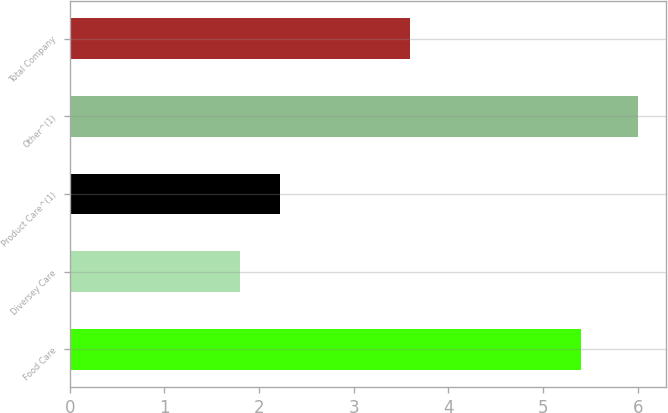Convert chart. <chart><loc_0><loc_0><loc_500><loc_500><bar_chart><fcel>Food Care<fcel>Diversey Care<fcel>Product Care^(1)<fcel>Other^(1)<fcel>Total Company<nl><fcel>5.4<fcel>1.8<fcel>2.22<fcel>6<fcel>3.6<nl></chart> 